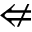<formula> <loc_0><loc_0><loc_500><loc_500>\ n L e f t a r r o w</formula> 